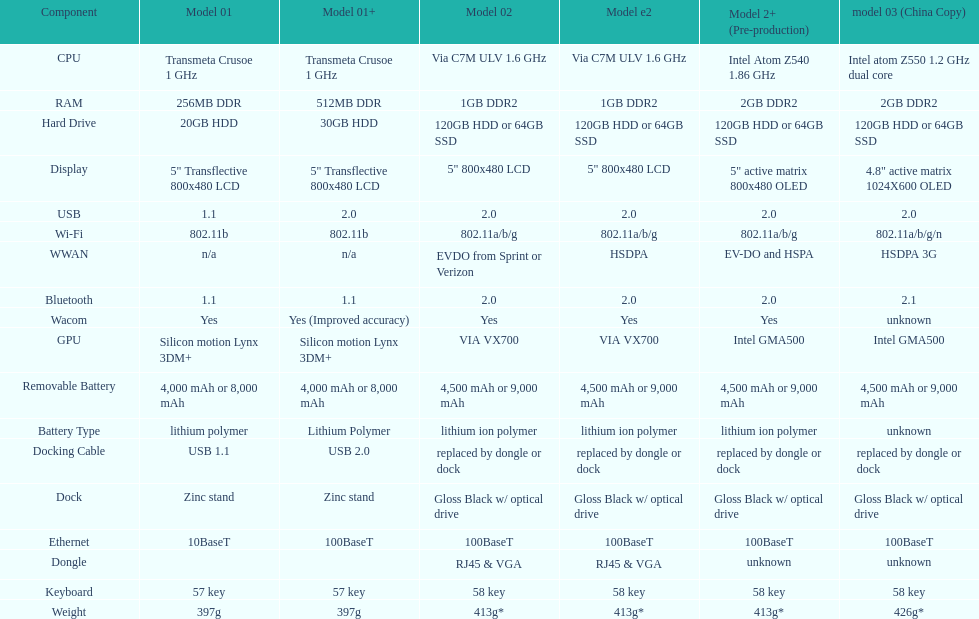How many models incorporate the use of a usb docking cable? 2. Help me parse the entirety of this table. {'header': ['Component', 'Model 01', 'Model 01+', 'Model 02', 'Model e2', 'Model 2+ (Pre-production)', 'model 03 (China Copy)'], 'rows': [['CPU', 'Transmeta Crusoe 1\xa0GHz', 'Transmeta Crusoe 1\xa0GHz', 'Via C7M ULV 1.6\xa0GHz', 'Via C7M ULV 1.6\xa0GHz', 'Intel Atom Z540 1.86\xa0GHz', 'Intel atom Z550 1.2\xa0GHz dual core'], ['RAM', '256MB DDR', '512MB DDR', '1GB DDR2', '1GB DDR2', '2GB DDR2', '2GB DDR2'], ['Hard Drive', '20GB HDD', '30GB HDD', '120GB HDD or 64GB SSD', '120GB HDD or 64GB SSD', '120GB HDD or 64GB SSD', '120GB HDD or 64GB SSD'], ['Display', '5" Transflective 800x480 LCD', '5" Transflective 800x480 LCD', '5" 800x480 LCD', '5" 800x480 LCD', '5" active matrix 800x480 OLED', '4.8" active matrix 1024X600 OLED'], ['USB', '1.1', '2.0', '2.0', '2.0', '2.0', '2.0'], ['Wi-Fi', '802.11b', '802.11b', '802.11a/b/g', '802.11a/b/g', '802.11a/b/g', '802.11a/b/g/n'], ['WWAN', 'n/a', 'n/a', 'EVDO from Sprint or Verizon', 'HSDPA', 'EV-DO and HSPA', 'HSDPA 3G'], ['Bluetooth', '1.1', '1.1', '2.0', '2.0', '2.0', '2.1'], ['Wacom', 'Yes', 'Yes (Improved accuracy)', 'Yes', 'Yes', 'Yes', 'unknown'], ['GPU', 'Silicon motion Lynx 3DM+', 'Silicon motion Lynx 3DM+', 'VIA VX700', 'VIA VX700', 'Intel GMA500', 'Intel GMA500'], ['Removable Battery', '4,000 mAh or 8,000 mAh', '4,000 mAh or 8,000 mAh', '4,500 mAh or 9,000 mAh', '4,500 mAh or 9,000 mAh', '4,500 mAh or 9,000 mAh', '4,500 mAh or 9,000 mAh'], ['Battery Type', 'lithium polymer', 'Lithium Polymer', 'lithium ion polymer', 'lithium ion polymer', 'lithium ion polymer', 'unknown'], ['Docking Cable', 'USB 1.1', 'USB 2.0', 'replaced by dongle or dock', 'replaced by dongle or dock', 'replaced by dongle or dock', 'replaced by dongle or dock'], ['Dock', 'Zinc stand', 'Zinc stand', 'Gloss Black w/ optical drive', 'Gloss Black w/ optical drive', 'Gloss Black w/ optical drive', 'Gloss Black w/ optical drive'], ['Ethernet', '10BaseT', '100BaseT', '100BaseT', '100BaseT', '100BaseT', '100BaseT'], ['Dongle', '', '', 'RJ45 & VGA', 'RJ45 & VGA', 'unknown', 'unknown'], ['Keyboard', '57 key', '57 key', '58 key', '58 key', '58 key', '58 key'], ['Weight', '397g', '397g', '413g*', '413g*', '413g*', '426g*']]} 